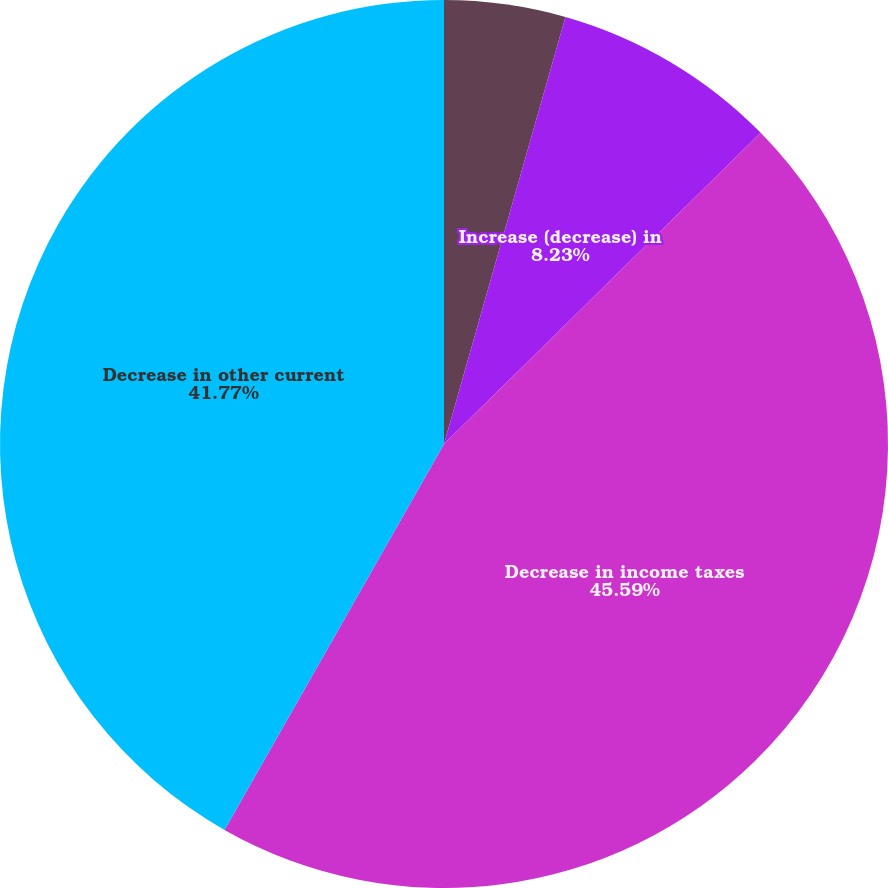Convert chart to OTSL. <chart><loc_0><loc_0><loc_500><loc_500><pie_chart><fcel>Decrease (increase) in other<fcel>Increase (decrease) in<fcel>Decrease in income taxes<fcel>Decrease in other current<nl><fcel>4.41%<fcel>8.23%<fcel>45.59%<fcel>41.77%<nl></chart> 